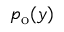Convert formula to latex. <formula><loc_0><loc_0><loc_500><loc_500>p _ { o } ( y )</formula> 